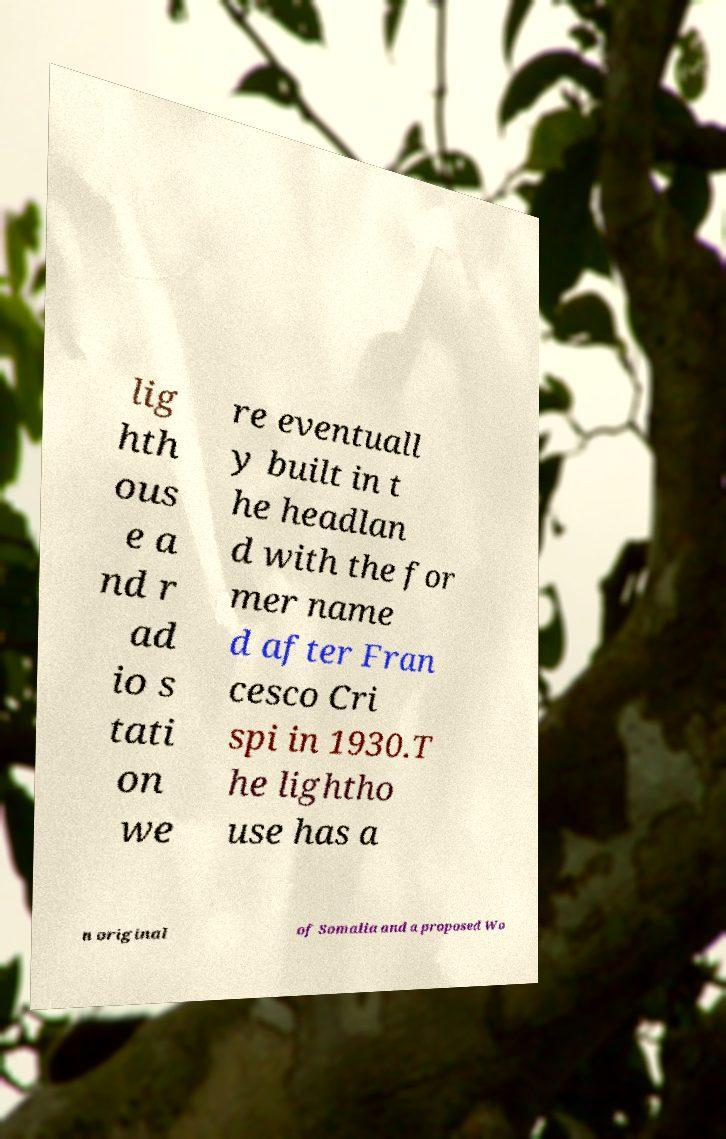Please read and relay the text visible in this image. What does it say? lig hth ous e a nd r ad io s tati on we re eventuall y built in t he headlan d with the for mer name d after Fran cesco Cri spi in 1930.T he lightho use has a n original of Somalia and a proposed Wo 